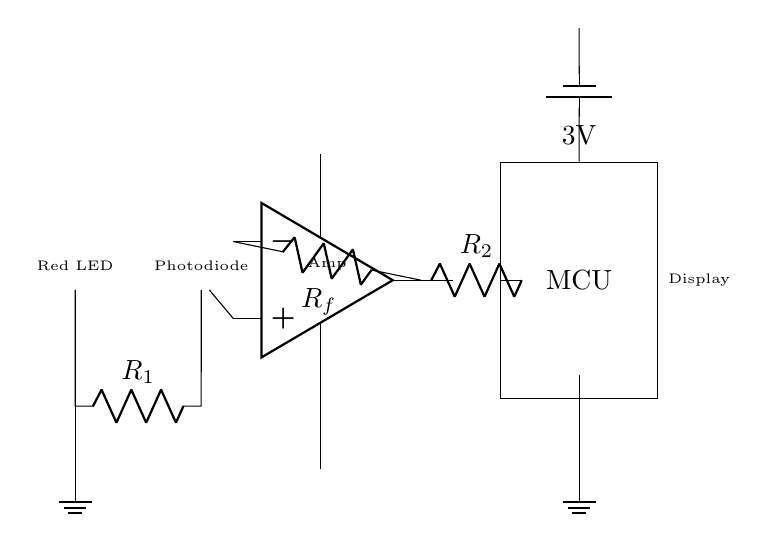What is the type of the light source in this circuit? The light source in this circuit is a red LED, which is indicated by its label in the diagram.
Answer: Red LED What is the voltage supplied to the microcontroller? The voltage supplied to the microcontroller is 3 volts, as shown by the battery symbol connecting to it.
Answer: 3 volts How many resistors are present in the circuit? There are two resistors present in the circuit, labeled as R1 and R2.
Answer: Two What does the photodiode do in this circuit? The photodiode detects the light coming from the LED and converts it into an electrical current, which is essential for measuring blood oxygen levels.
Answer: Detects light What is the role of the operational amplifier in this circuit? The operational amplifier amplifies the signal from the photodiode, enhancing its output so that it can be processed by the microcontroller. This is crucial for accurate measurement.
Answer: Signal amplification What happens to the signal after it passes through the operational amplifier? After passing through the operational amplifier, the amplified signal is sent to a resistor (Rf) and then directed towards the microcontroller for further processing and display.
Answer: Amplified signal to microcontroller What type of circuit is represented in the diagram? The circuit represented in the diagram is an optoelectronic sensor circuit, as it combines a light source (LED) and a light detector (photodiode) to measure oxygen saturation in blood.
Answer: Optoelectronic sensor 